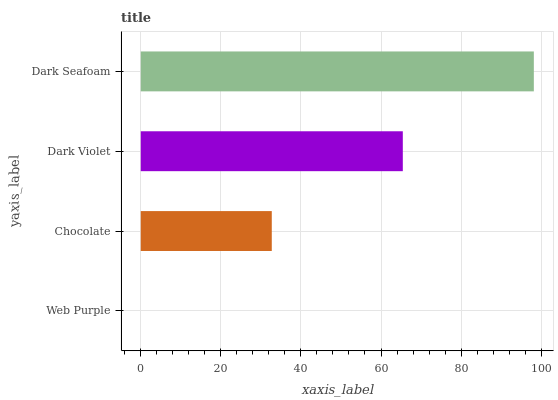Is Web Purple the minimum?
Answer yes or no. Yes. Is Dark Seafoam the maximum?
Answer yes or no. Yes. Is Chocolate the minimum?
Answer yes or no. No. Is Chocolate the maximum?
Answer yes or no. No. Is Chocolate greater than Web Purple?
Answer yes or no. Yes. Is Web Purple less than Chocolate?
Answer yes or no. Yes. Is Web Purple greater than Chocolate?
Answer yes or no. No. Is Chocolate less than Web Purple?
Answer yes or no. No. Is Dark Violet the high median?
Answer yes or no. Yes. Is Chocolate the low median?
Answer yes or no. Yes. Is Chocolate the high median?
Answer yes or no. No. Is Dark Seafoam the low median?
Answer yes or no. No. 